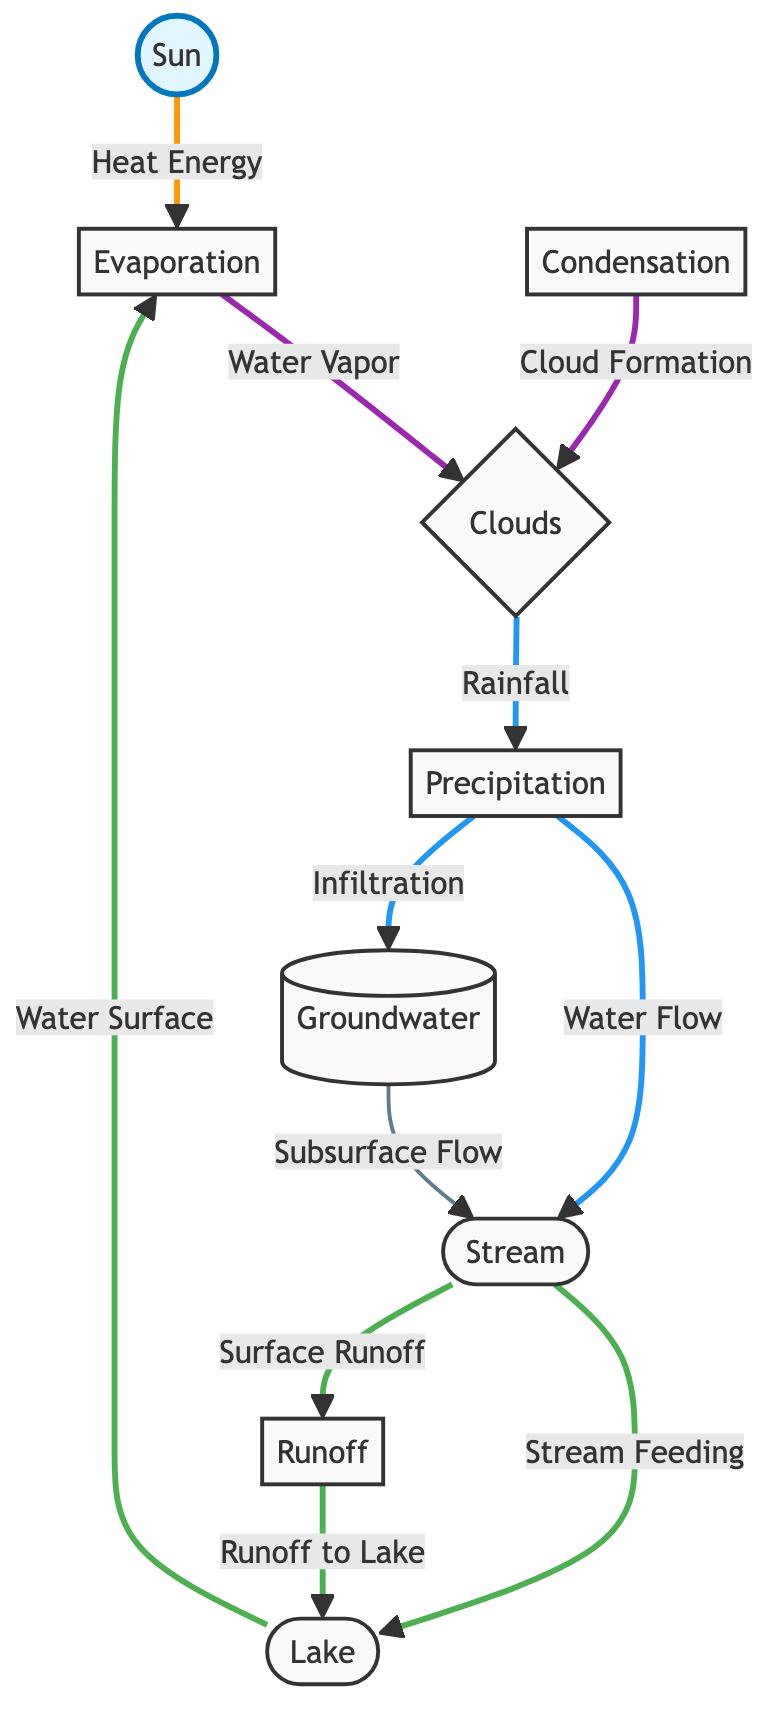What is the main source of heat energy in the water cycle? The diagram shows an arrow pointing from the Sun to Evaporation, indicating that the Sun provides heat energy which drives the process of evaporation.
Answer: Sun How many main processes are depicted in the water cycle diagram? By counting the processes represented as nodes, we identify Evaporation, Condensation, Precipitation, and Runoff, totaling four main processes in the water cycle diagram.
Answer: 4 What connects condensation to clouds? The diagram shows an arrow labeled "Cloud Formation" leading from Condensation to Clouds, indicating that condensation results in the formation of clouds.
Answer: Cloud Formation Where does the stream receive water from? The diagram indicates that the stream receives water from Precipitation through the path "Water Flow" and from Groundwater through the path "Subsurface Flow." Both connections allow the stream to be fed by these sources.
Answer: Precipitation and Groundwater What leads to the formation of clouds in the diagram? The connection is shown with an arrow from Evaporation to Clouds labeled "Water Vapor," followed by Condensation connecting to Clouds, meaning that water vapor from evaporation condenses to form clouds.
Answer: Water Vapor What is the process by which water moves from the lake back to the atmosphere? The diagram indicates that evaporation from the lake returns water to the atmosphere, which is labeled as the process of Evaporation.
Answer: Evaporation Which node directly connects the stream to the lake in the diagram? An analysis of the diagram shows a direct connection between Stream and Lake, representing water flow from the stream into the lake.
Answer: Lake What is the label for the type of flow that moves water from the ground to the stream? The diagram contains a connection from Groundwater to Stream labeled as "Subsurface Flow," indicating how water flows from the ground to the stream.
Answer: Subsurface Flow What happens after precipitation occurs according to the water cycle diagram? The diagram shows that after precipitation, the water can flow to the stream or infiltrate into the groundwater, indicating these as potential paths following precipitation.
Answer: Water Flow and Infiltration 